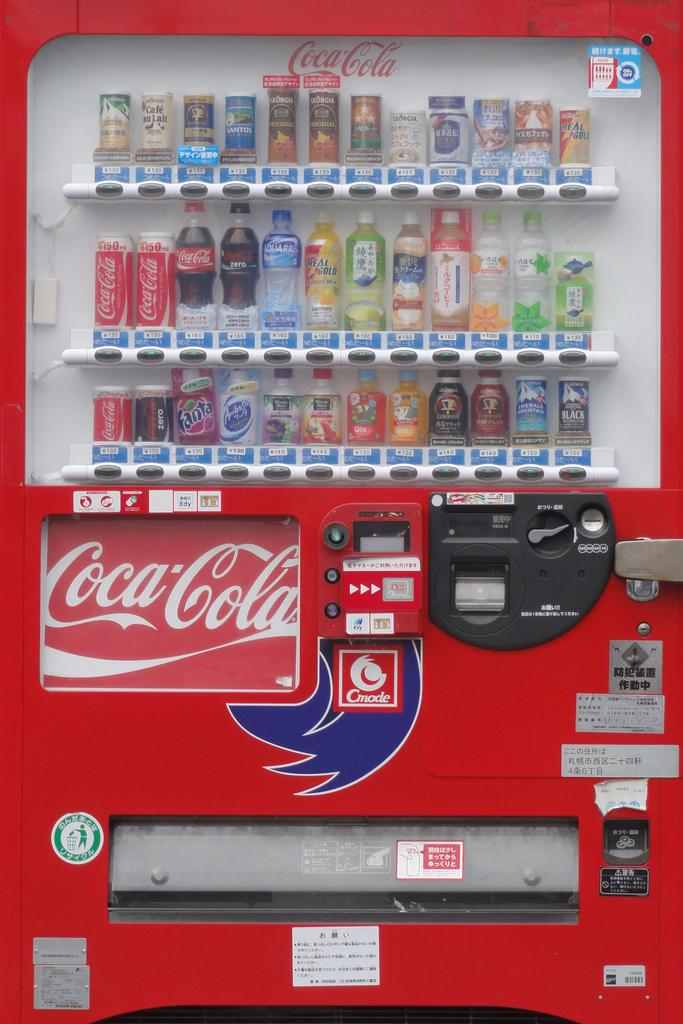What is the main object in the image? There is a vending machine in the image. What can be found inside the vending machine? The vending machine is full of cool drinks. What type of horn can be seen on the vending machine in the image? There is no horn present on the vending machine in the image. What vegetables are available for purchase in the vending machine? The vending machine is full of cool drinks, not vegetables. 